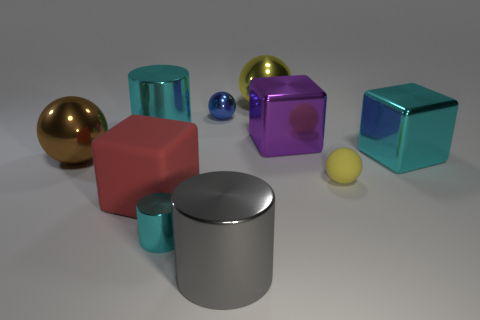Is the small yellow matte thing the same shape as the large rubber object?
Make the answer very short. No. There is a cyan object that is the same shape as the big red rubber thing; what is its size?
Give a very brief answer. Large. Is the size of the cyan cylinder that is in front of the red block the same as the big brown ball?
Offer a terse response. No. How big is the sphere that is to the right of the blue thing and in front of the tiny metal ball?
Keep it short and to the point. Small. There is a large thing that is the same color as the small matte ball; what material is it?
Make the answer very short. Metal. How many large metallic blocks have the same color as the large matte block?
Give a very brief answer. 0. Are there an equal number of large yellow metallic objects in front of the gray shiny thing and matte cubes?
Give a very brief answer. No. The big rubber cube has what color?
Offer a very short reply. Red. What size is the brown thing that is the same material as the big purple thing?
Your response must be concise. Large. The other tiny object that is the same material as the blue thing is what color?
Provide a succinct answer. Cyan. 